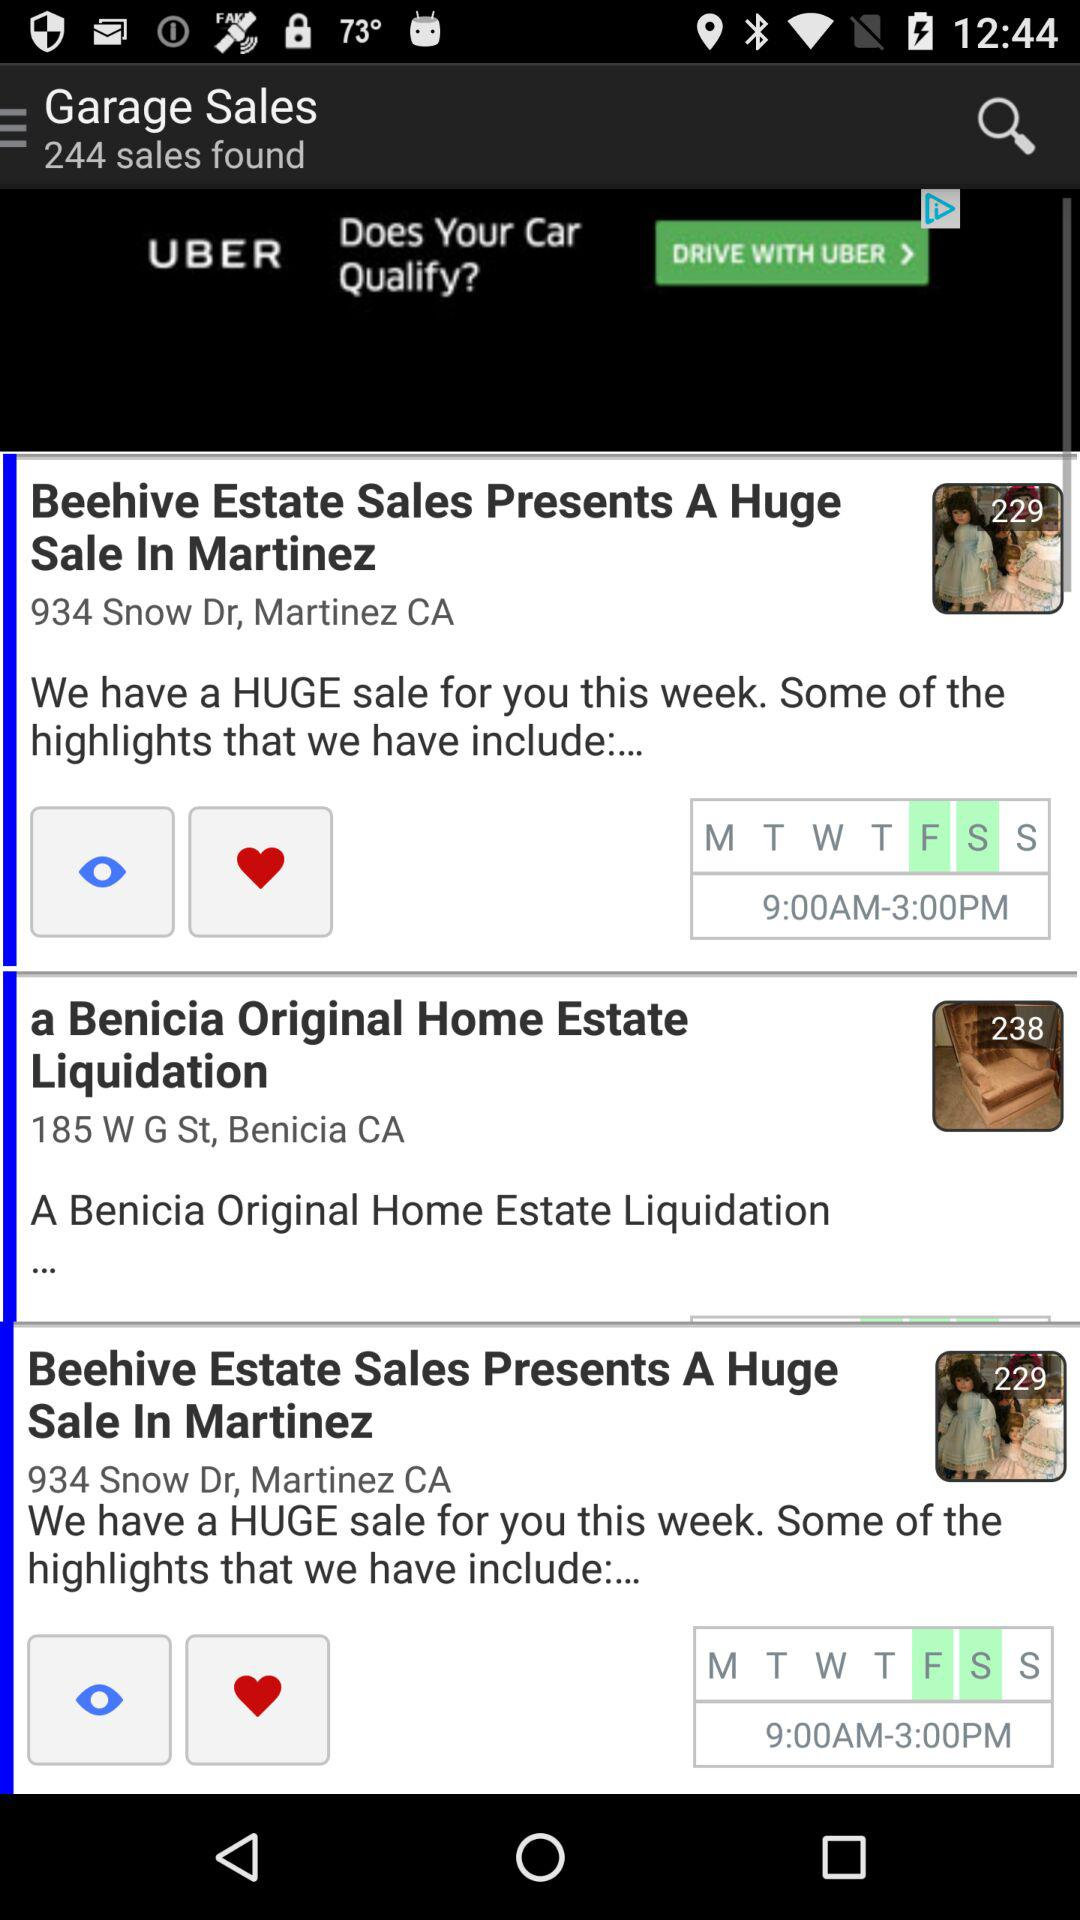On what days is "a Benicia Original Home Estate Liquidation" held?
When the provided information is insufficient, respond with <no answer>. <no answer> 